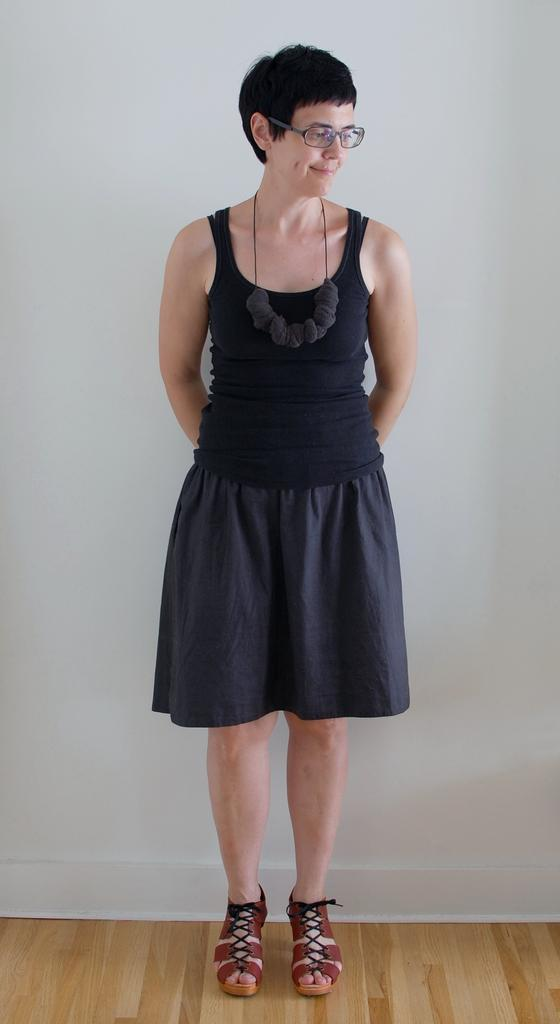Where was the image taken? The image was taken indoors. What can be seen at the bottom of the image? There is a floor visible at the bottom of the image. What is visible in the background of the image? There is a wall in the background of the image. Who is present in the image? A woman is standing in the middle of the image. What surface is the woman standing on? The woman is standing on the floor. What type of class is the woman attending in the image? There is no indication of a class or any educational setting in the image. 